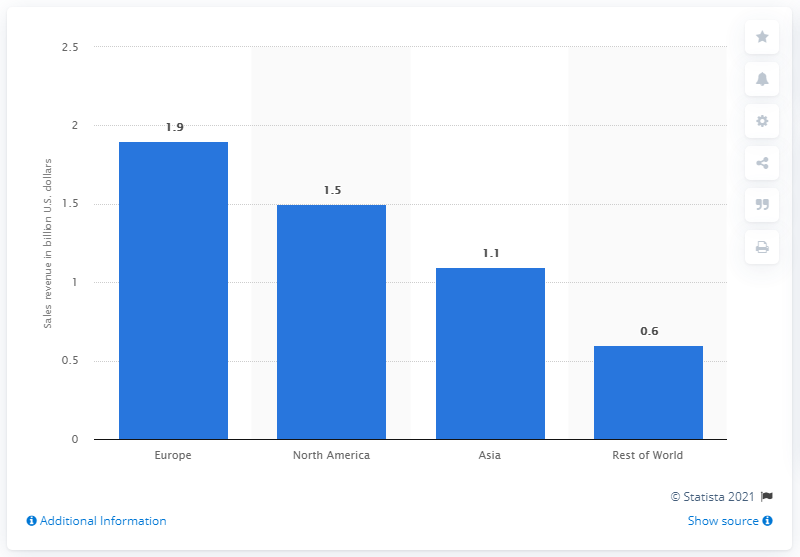Identify some key points in this picture. The estimated size of the VR gaming market in North America is 1.5... 